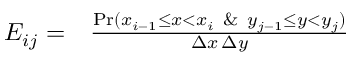Convert formula to latex. <formula><loc_0><loc_0><loc_500><loc_500>\begin{array} { r l } { E _ { i j } = } & \frac { P r ( x _ { i - 1 } \leq x < x _ { i } \ \& \ y _ { j - 1 } \leq y < y _ { j } ) } { \Delta x \, \Delta y } } \end{array}</formula> 